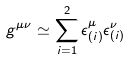<formula> <loc_0><loc_0><loc_500><loc_500>g ^ { \mu \nu } \simeq \sum _ { i = 1 } ^ { 2 } \epsilon _ { ( i ) } ^ { \mu } \epsilon _ { ( i ) } ^ { \nu }</formula> 